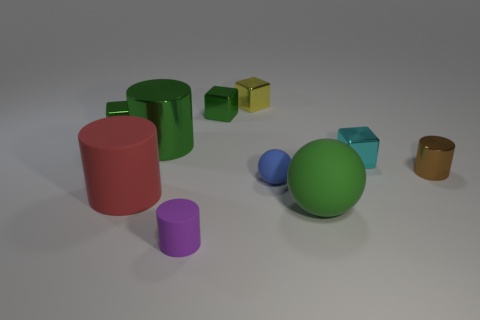Is there a tiny blue ball that has the same material as the small cyan thing?
Your answer should be very brief. No. There is another big matte object that is the same shape as the purple matte thing; what is its color?
Ensure brevity in your answer.  Red. Are there fewer tiny purple cylinders on the left side of the tiny matte ball than purple matte cylinders that are in front of the tiny purple cylinder?
Offer a very short reply. No. How many other objects are the same shape as the big red matte thing?
Offer a very short reply. 3. Is the number of matte balls right of the green matte thing less than the number of gray cubes?
Your answer should be very brief. No. What is the material of the block left of the red thing?
Give a very brief answer. Metal. What number of other things are there of the same size as the green cylinder?
Make the answer very short. 2. Are there fewer green shiny blocks than cyan metal cubes?
Provide a short and direct response. No. What is the shape of the tiny blue object?
Provide a succinct answer. Sphere. There is a large cylinder that is in front of the small brown object; is it the same color as the large sphere?
Your response must be concise. No. 